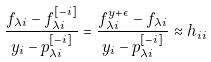Convert formula to latex. <formula><loc_0><loc_0><loc_500><loc_500>\frac { f _ { \lambda i } - f _ { \lambda i } ^ { [ - i ] } } { y _ { i } - p _ { \lambda i } ^ { [ - i ] } } = \frac { f _ { \lambda i } ^ { y + \epsilon } - f _ { \lambda i } } { y _ { i } - p _ { \lambda i } ^ { [ - i ] } } \approx h _ { i i }</formula> 